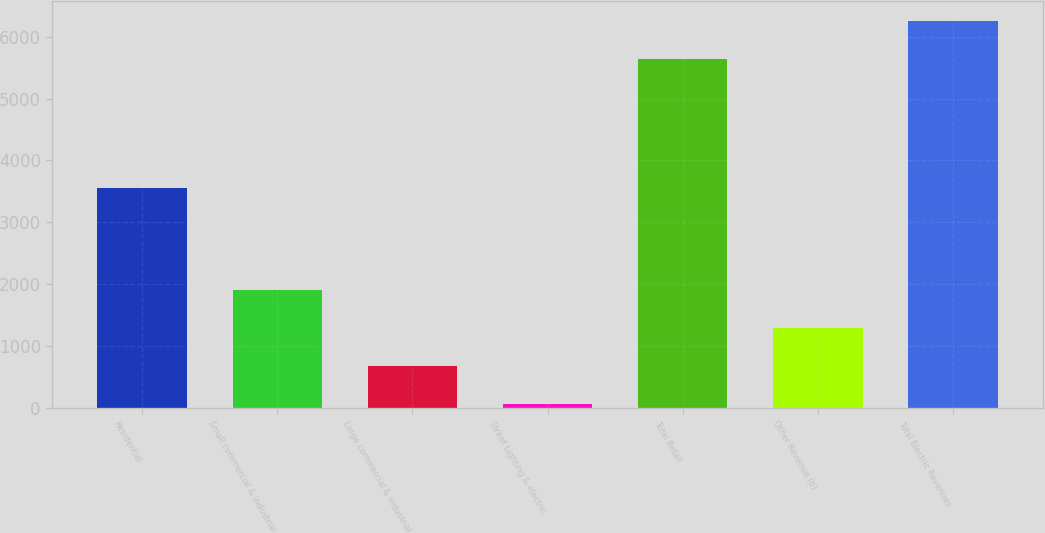Convert chart. <chart><loc_0><loc_0><loc_500><loc_500><bar_chart><fcel>Residential<fcel>Small commercial & industrial<fcel>Large commercial & industrial<fcel>Street Lighting & electric<fcel>Total Retail<fcel>Other Revenue (b)<fcel>Total Electric Revenues<nl><fcel>3549<fcel>1904.6<fcel>676.2<fcel>62<fcel>5647<fcel>1290.4<fcel>6261.2<nl></chart> 